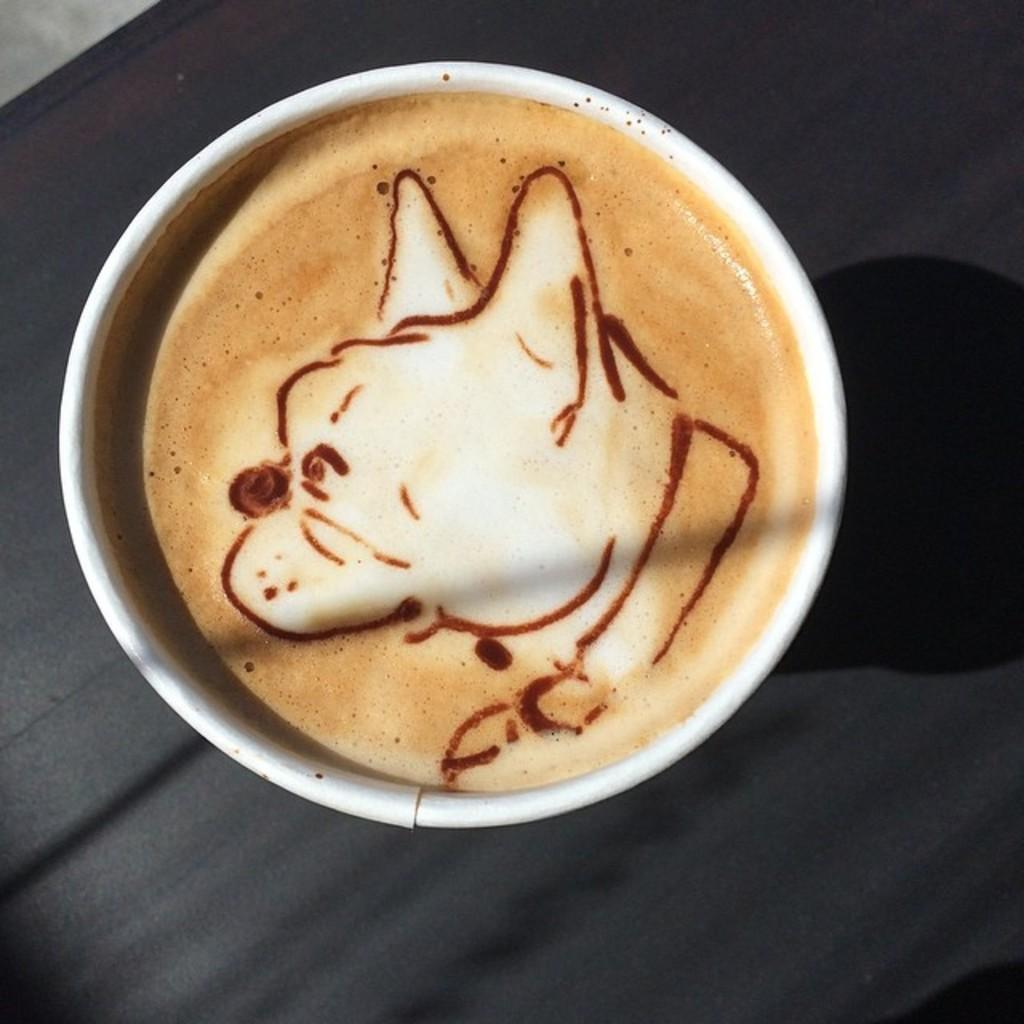What is in the cup that is visible in the image? There is a cup of coffee in the image. What design can be seen on the coffee? The coffee has latte art. What color is the background in the image? The background appears black in color. What type of clouds can be seen in the image? There are no clouds visible in the image; the background appears black in color. 